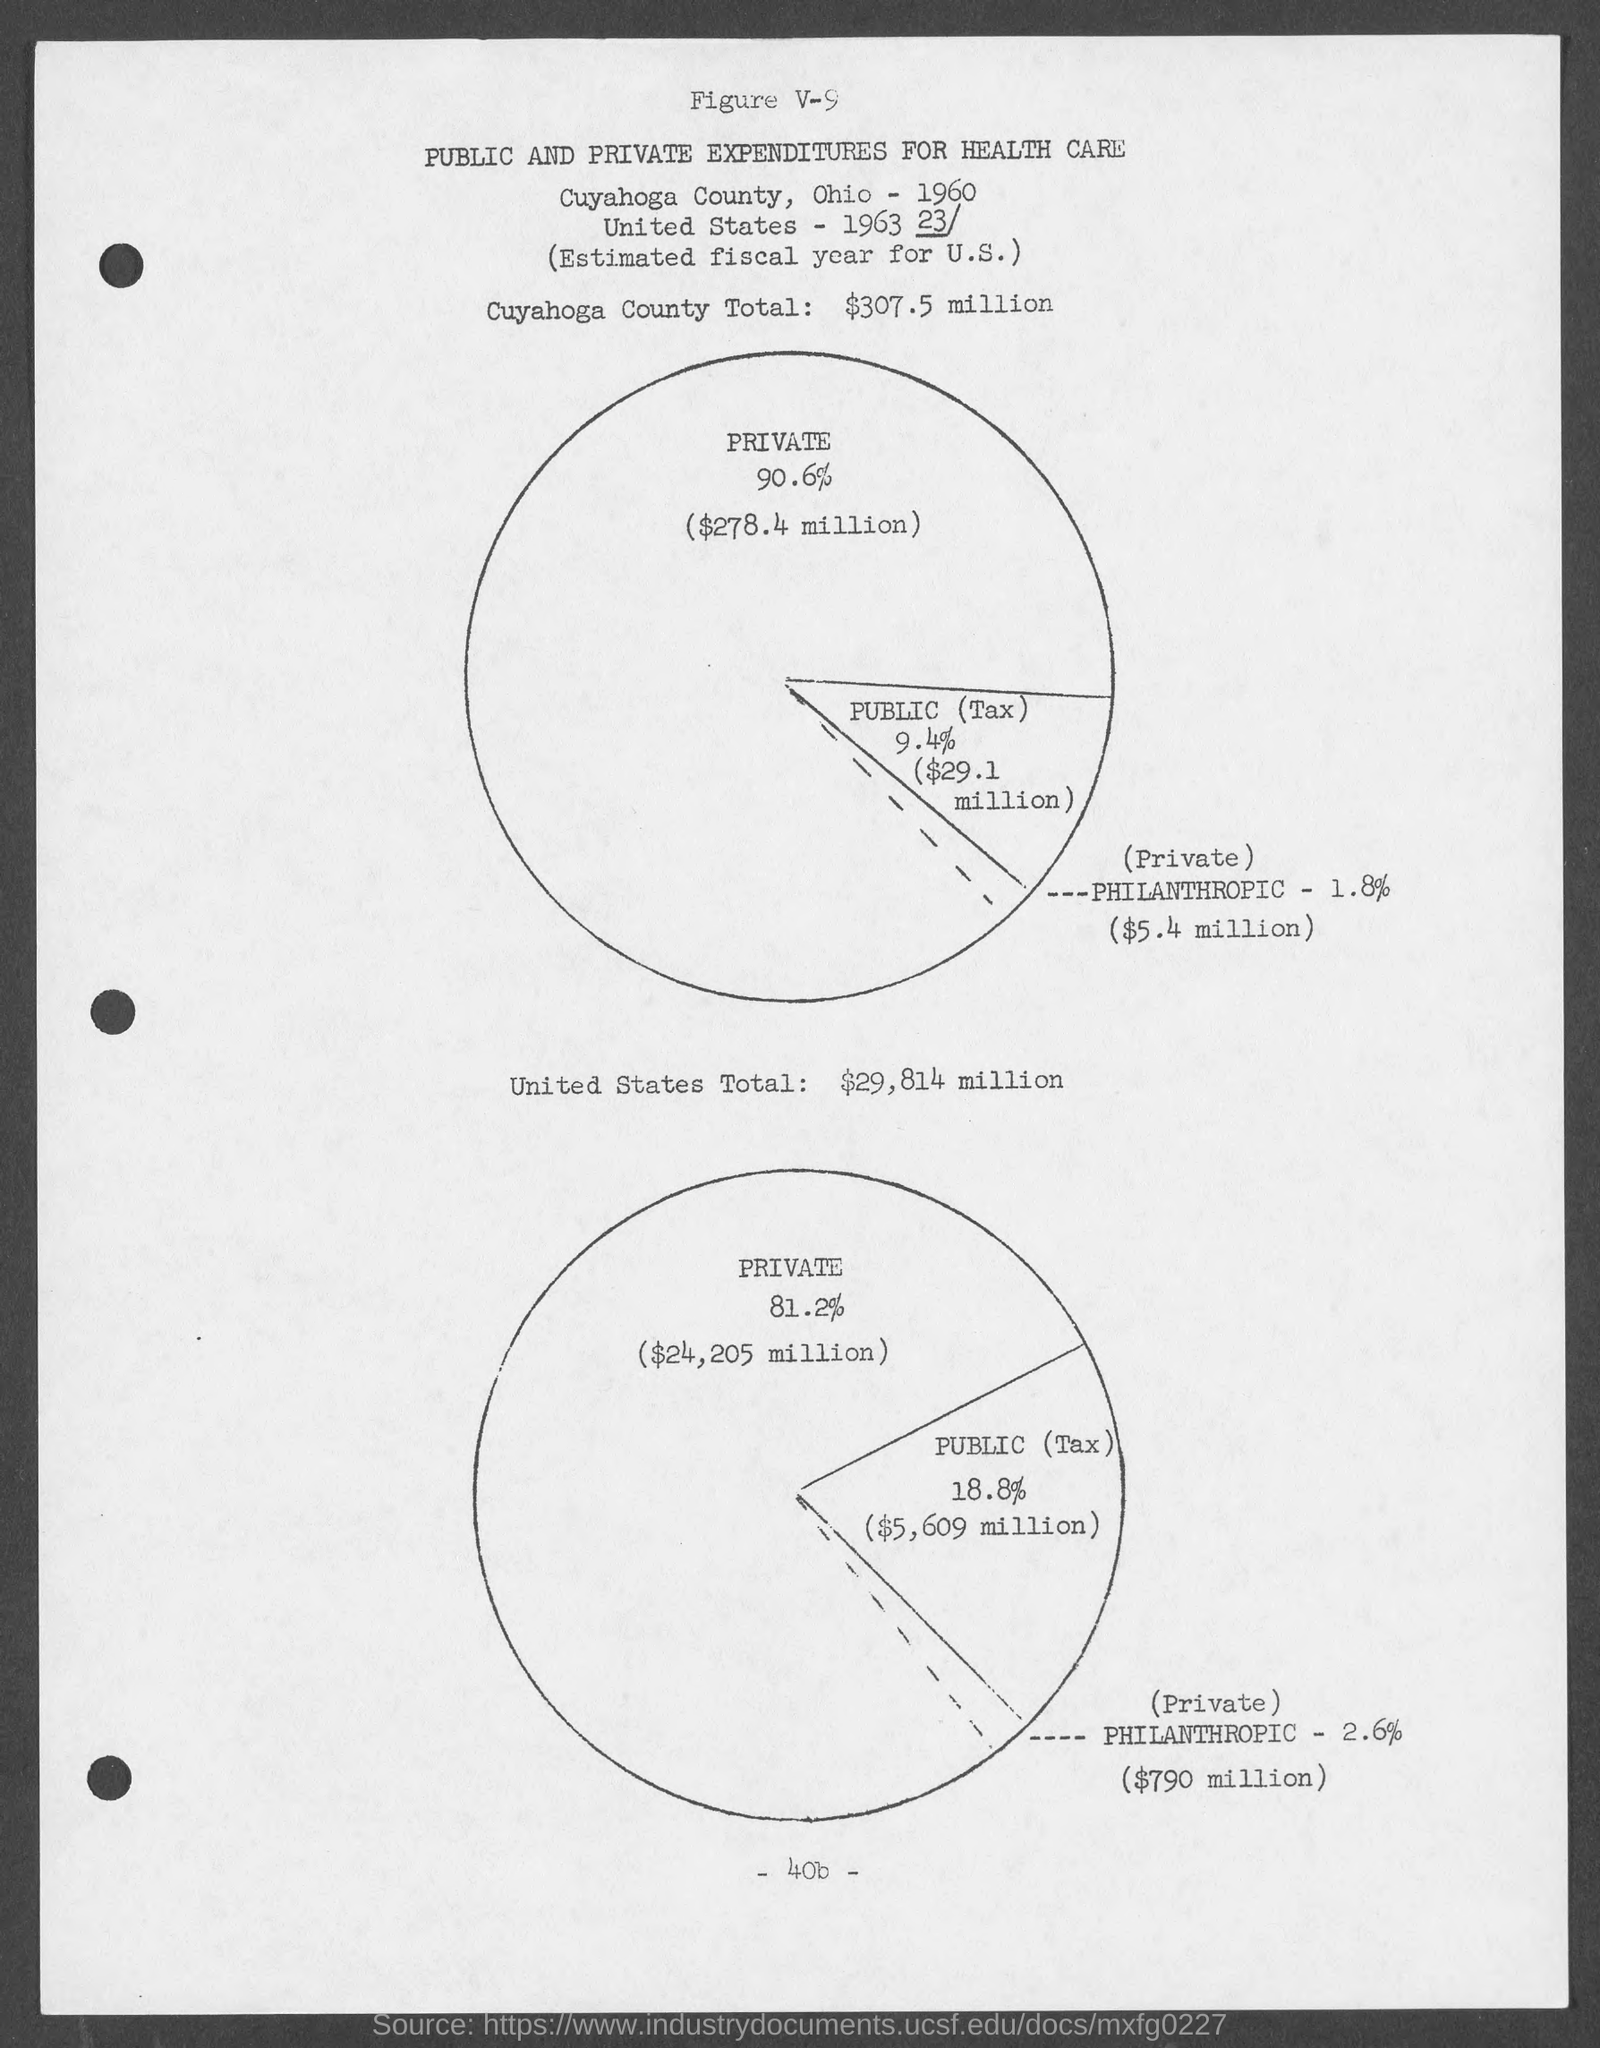Identify some key points in this picture. The United States has a total of $29,814 million. The total amount for Cuyahoga County is $307.5 million. 